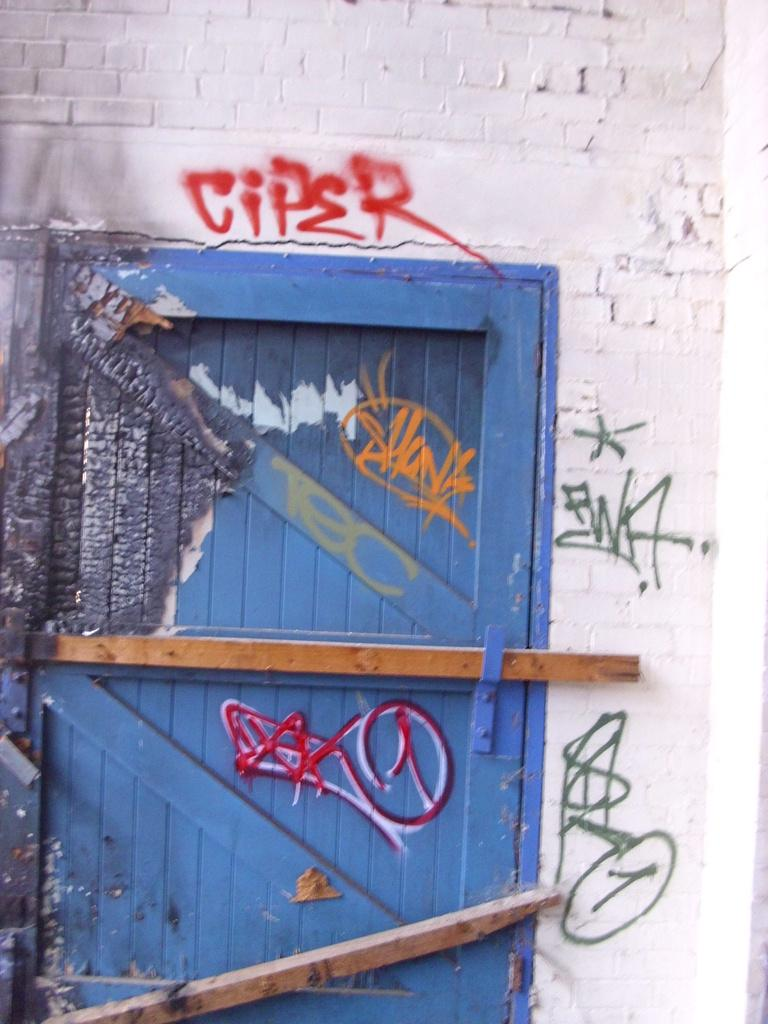What is one of the main features of the image? There is a door in the image. What else can be seen in the image? There is a wall in the image. What is unique about the door and wall in the image? There is graffiti on the door and the wall. Can you see any waves crashing against the door in the image? There are no waves present in the image; it features a door and a wall with graffiti. What type of crow is perched on the graffiti in the image? There is no crow present in the image; it only features a door and a wall with graffiti. 